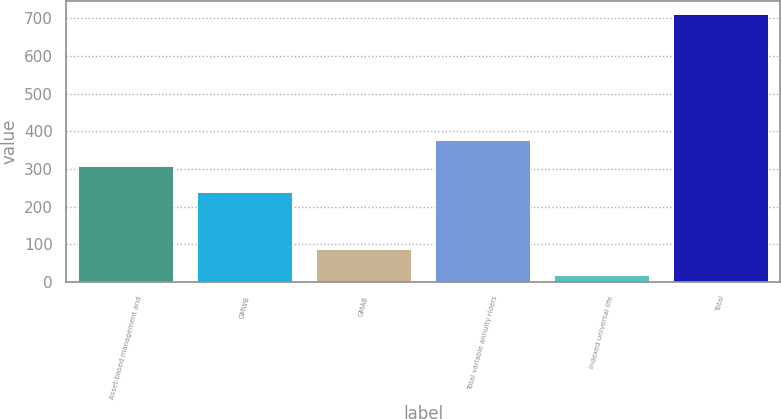<chart> <loc_0><loc_0><loc_500><loc_500><bar_chart><fcel>Asset-based management and<fcel>GMWB<fcel>GMAB<fcel>Total variable annuity riders<fcel>Indexed universal life<fcel>Total<nl><fcel>308.3<fcel>239<fcel>87.3<fcel>378<fcel>18<fcel>711<nl></chart> 